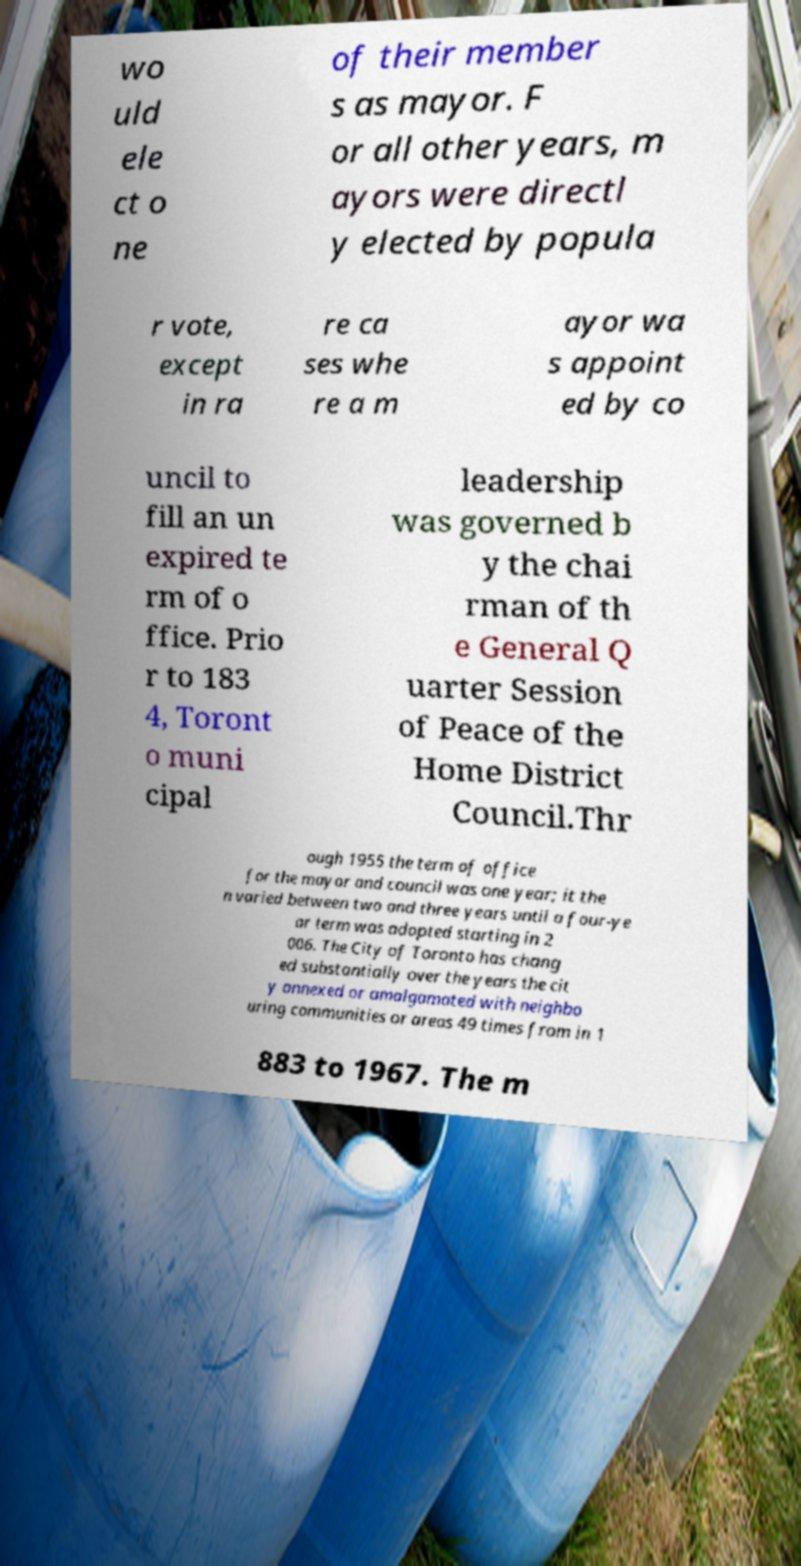Could you assist in decoding the text presented in this image and type it out clearly? wo uld ele ct o ne of their member s as mayor. F or all other years, m ayors were directl y elected by popula r vote, except in ra re ca ses whe re a m ayor wa s appoint ed by co uncil to fill an un expired te rm of o ffice. Prio r to 183 4, Toront o muni cipal leadership was governed b y the chai rman of th e General Q uarter Session of Peace of the Home District Council.Thr ough 1955 the term of office for the mayor and council was one year; it the n varied between two and three years until a four-ye ar term was adopted starting in 2 006. The City of Toronto has chang ed substantially over the years the cit y annexed or amalgamated with neighbo uring communities or areas 49 times from in 1 883 to 1967. The m 